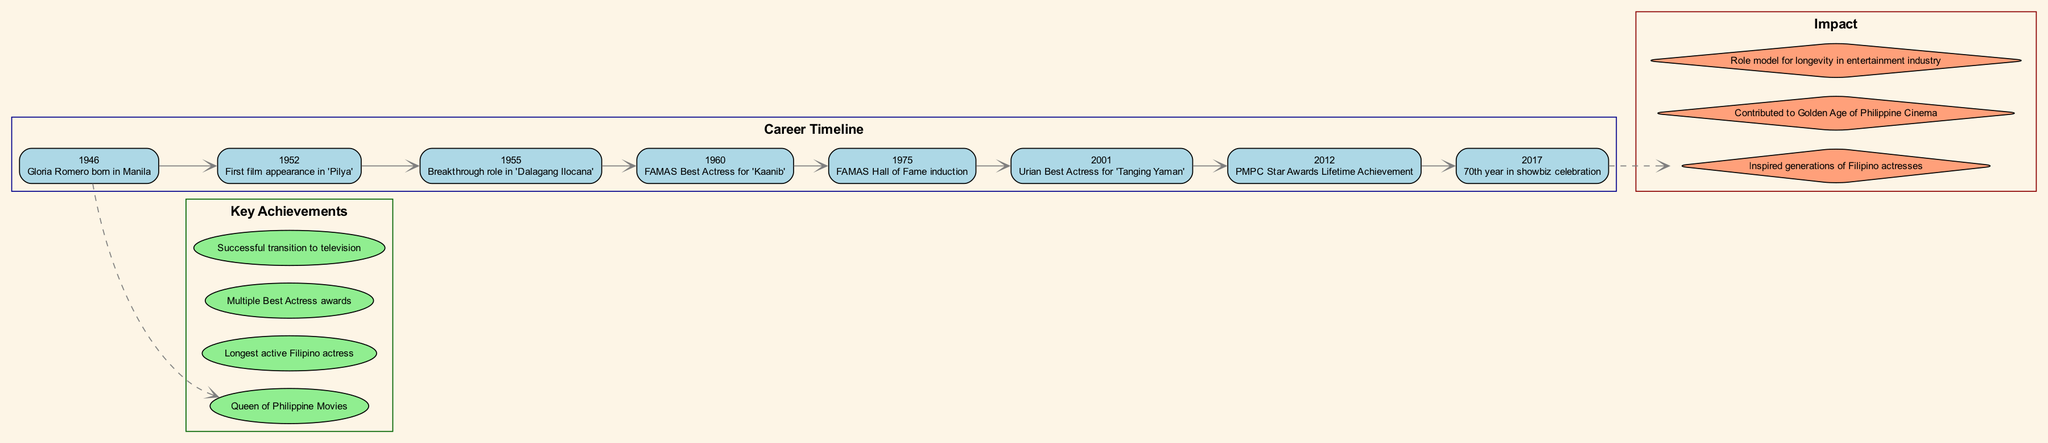What year did Gloria Romero win FAMAS Best Actress? The diagram shows that Gloria Romero won the FAMAS Best Actress award in the year 1960 for her performance in 'Kaanib'.
Answer: 1960 What significant event happened in 1975? According to the timeline, the significant event that happened in 1975 was Gloria Romero's induction into the FAMAS Hall of Fame.
Answer: FAMAS Hall of Fame induction How many Key Achievements are listed? The diagram states that there are four Key Achievements listed under Gloria Romero's profile.
Answer: 4 What is Gloria Romero referred to as in Philippine cinema? The diagram indicates that Gloria Romero is referred to as the "Queen of Philippine Movies".
Answer: Queen of Philippine Movies Which year marks the start of Gloria Romero's film career? The timeline identifies 1952 as the year when Gloria Romero made her first film appearance in 'Pilya', marking the beginning of her film career.
Answer: 1952 What type of node connects the timeline to the Key Achievements? The diagram specifically features dashed edges connecting the timeline nodes to the Key Achievements node, indicating a relationship between events and achievements.
Answer: Dashed edges Which milestone celebrates Gloria Romero's 70th year in showbiz? The diagram notes that the milestone celebrating Gloria Romero's 70th year in showbiz occurred in the year 2017.
Answer: 2017 What impact did Gloria Romero have on future actresses? The diagram shows that one of the impacts Gloria Romero had is that she inspired generations of Filipino actresses.
Answer: Inspired generations of Filipino actresses What color represents the Key Achievements in the diagram? The Key Achievements section of the diagram is filled with light green color as indicated by the visual representation.
Answer: Light green 